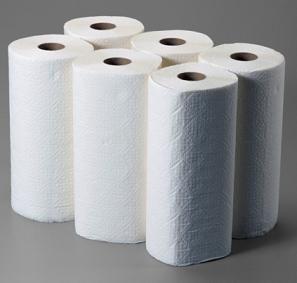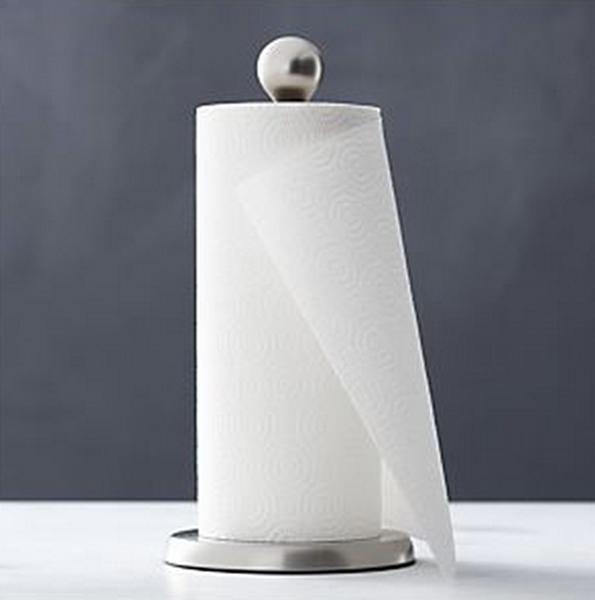The first image is the image on the left, the second image is the image on the right. For the images shown, is this caption "There is at least one paper towel roll hanging" true? Answer yes or no. No. The first image is the image on the left, the second image is the image on the right. Considering the images on both sides, is "A roll of paper towels is on a rack under a cabinet with the next towel hanging from the back." valid? Answer yes or no. No. 